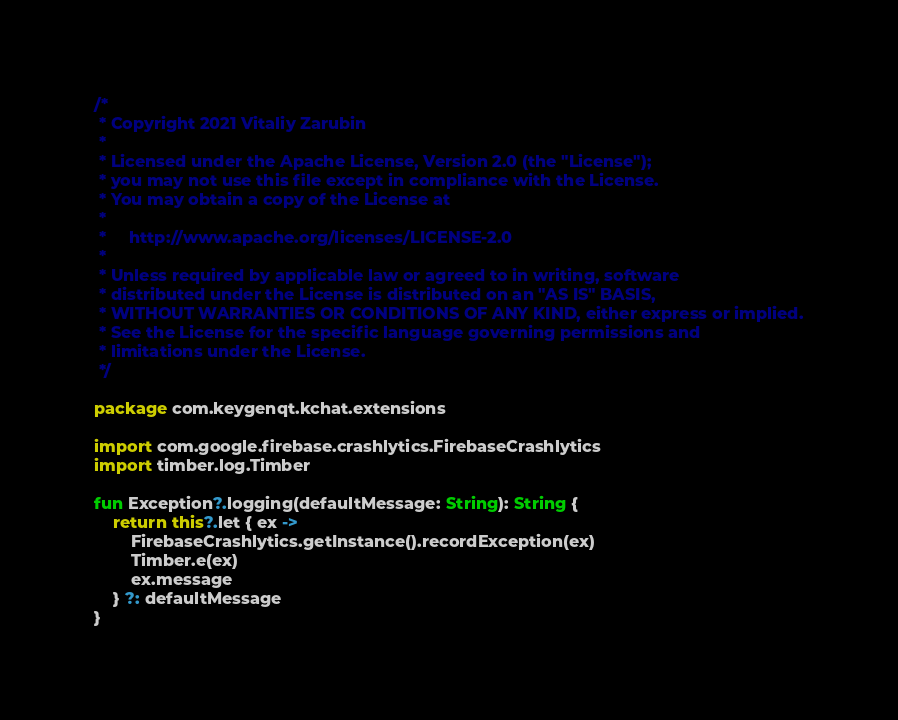Convert code to text. <code><loc_0><loc_0><loc_500><loc_500><_Kotlin_>/*
 * Copyright 2021 Vitaliy Zarubin
 *
 * Licensed under the Apache License, Version 2.0 (the "License");
 * you may not use this file except in compliance with the License.
 * You may obtain a copy of the License at
 *
 *     http://www.apache.org/licenses/LICENSE-2.0
 *
 * Unless required by applicable law or agreed to in writing, software
 * distributed under the License is distributed on an "AS IS" BASIS,
 * WITHOUT WARRANTIES OR CONDITIONS OF ANY KIND, either express or implied.
 * See the License for the specific language governing permissions and
 * limitations under the License.
 */
 
package com.keygenqt.kchat.extensions

import com.google.firebase.crashlytics.FirebaseCrashlytics
import timber.log.Timber

fun Exception?.logging(defaultMessage: String): String {
    return this?.let { ex ->
        FirebaseCrashlytics.getInstance().recordException(ex)
        Timber.e(ex)
        ex.message
    } ?: defaultMessage
}</code> 